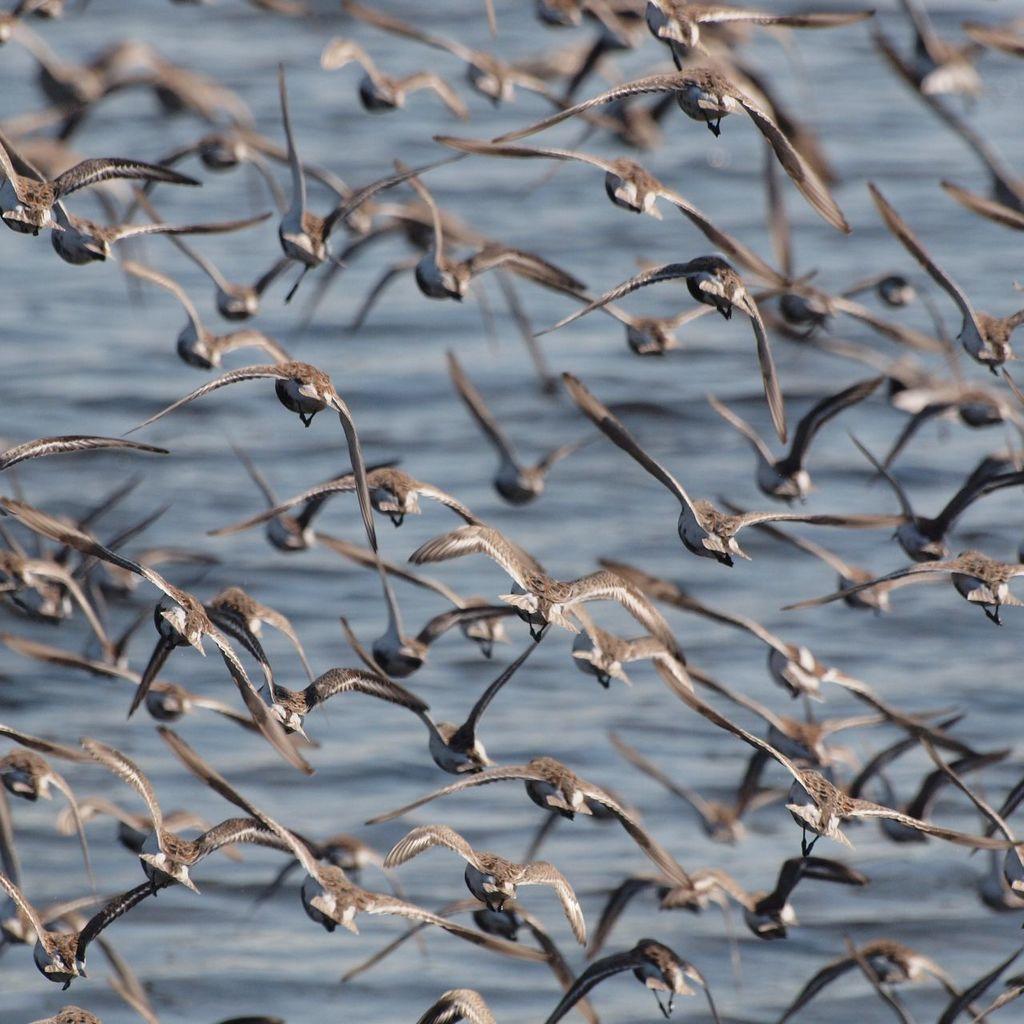In one or two sentences, can you explain what this image depicts? In this picture we can see a group of birds flying. In front of the birds, there is water. 